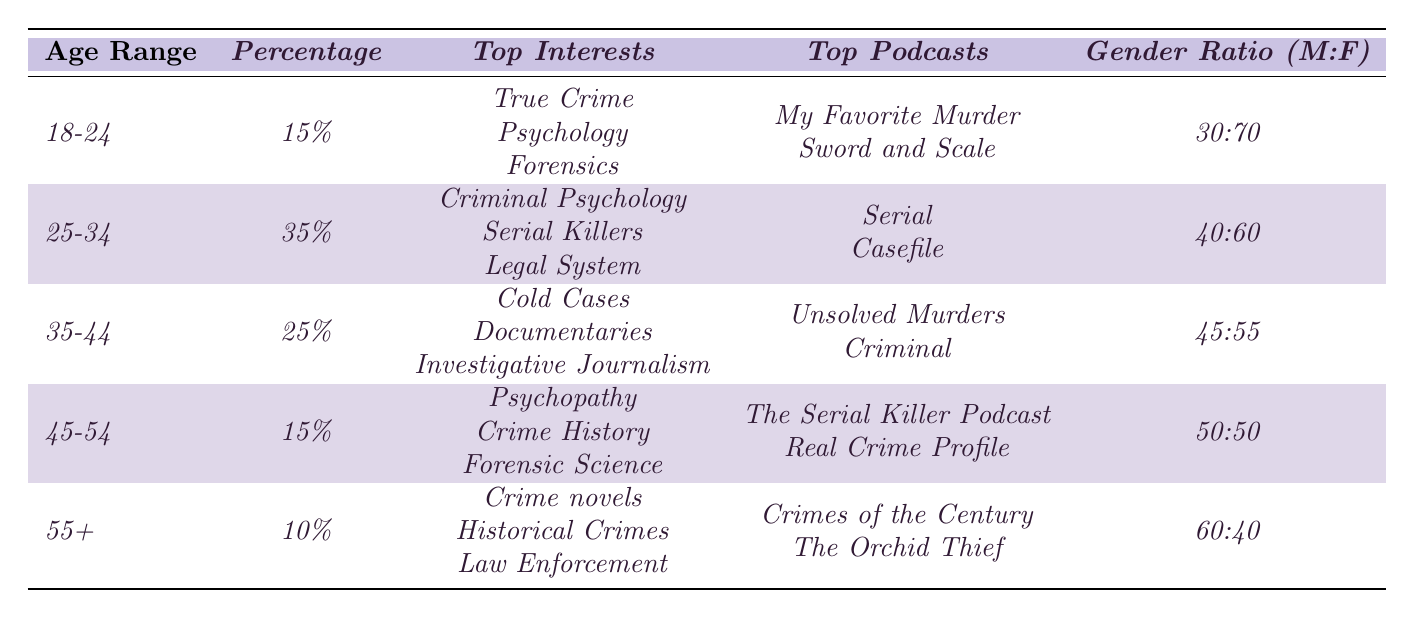What age range has the highest percentage of listeners? The table shows that the age range 25-34 has the highest percentage at 35%.
Answer: 25-34 How many listeners in the 18-24 age range are interested in psychology? The interests for the 18-24 age range include psychology, as listed in the table.
Answer: Yes What is the gender ratio for the 45-54 age range? The table lists the gender ratio for the 45-54 age range as 50:50.
Answer: 50:50 What percentage of listeners are 35-44 years old compared to those aged 55 and older? The percentage of listeners aged 35-44 is 25%, while those aged 55+ is 10%. The difference is 25% - 10% = 15%.
Answer: 15% Which interests are most common among listeners aged 25-34? For the 25-34 age range, the top interests are criminal psychology, serial killers, and the legal system, as stated in the table.
Answer: Criminal Psychology, Serial Killers, Legal System What is the average percentage of listeners across the age groups? To calculate the average, sum the percentages (15 + 35 + 25 + 15 + 10) = 100, then divide by the number of age groups (5). 100/5 = 20%.
Answer: 20% Is the percentage of male listeners in the 55+ age group higher than in the 18-24 age group? The male percentage for 55+ is 60%, while for 18-24, it is 30%. So, 60% > 30% is true.
Answer: Yes How many more people listen to crime podcasts in the 25-34 age range than the 45-54 age range? The 25-34 age range has 35% of the listeners, while the 45-54 age range has 15%. The difference is 35% - 15% = 20%.
Answer: 20% What is the gender ratio for the 35-44 age group? The table states that the gender ratio for the 35-44 age group is 45:55.
Answer: 45:55 Which age group listens to 'My Favorite Murder'? The table indicates that listeners aged 18-24 list 'My Favorite Murder' as one of their top podcasts.
Answer: 18-24 